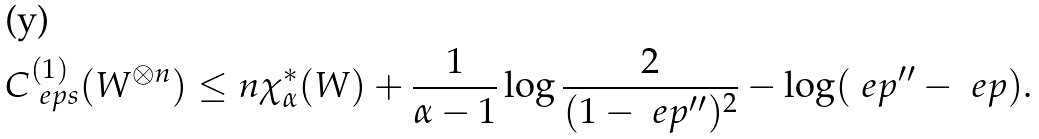Convert formula to latex. <formula><loc_0><loc_0><loc_500><loc_500>C ^ { ( 1 ) } _ { \ e p s } ( W ^ { \otimes n } ) \leq n \chi ^ { * } _ { \alpha } ( W ) + \frac { 1 } { \alpha - 1 } \log \frac { 2 } { ( 1 - \ e p ^ { \prime \prime } ) ^ { 2 } } - \log ( \ e p ^ { \prime \prime } - \ e p ) .</formula> 